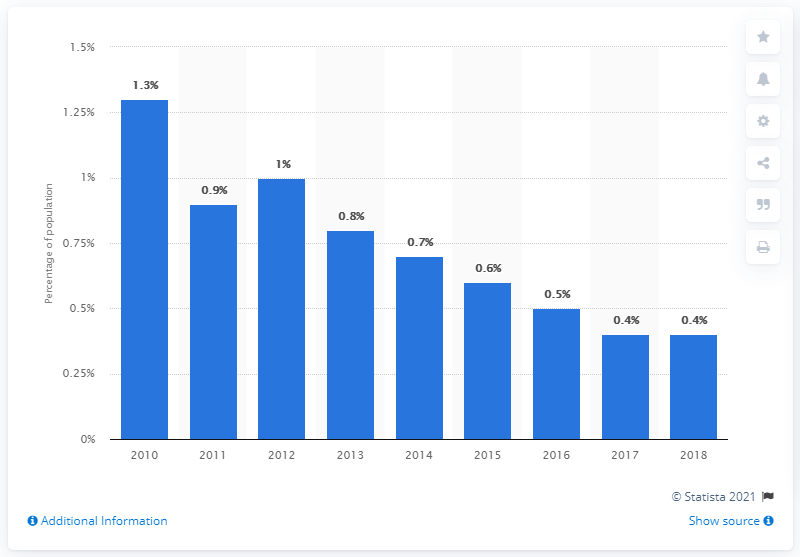List a handful of essential elements in this visual. In 2018, approximately 0.4% of the population of Uruguay was living on less than 3.20 US dollars per day, according to data. In 2010, approximately 13% of the population of Uruguay lived on less than 3.20 dollars per day, according to estimates. 